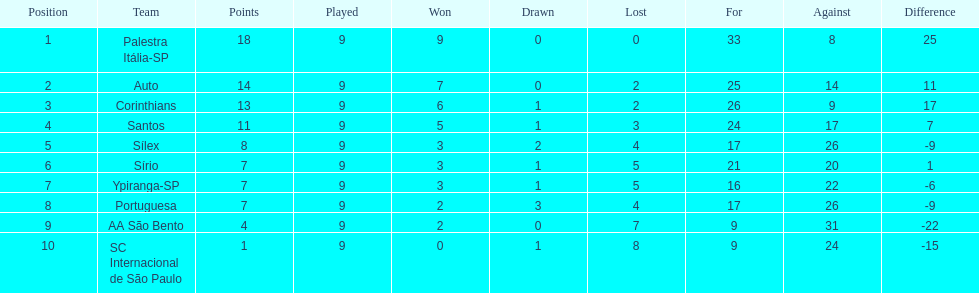In 1926 brazilian soccer, excluding the premier team, which other teams had triumphing records? Auto, Corinthians, Santos. 